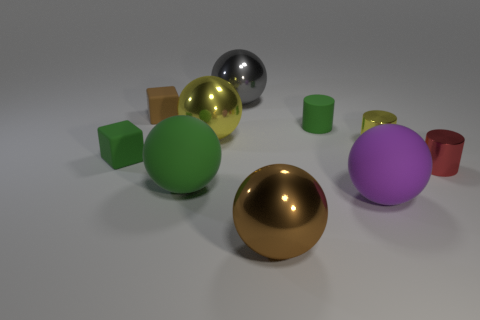Can you describe the surface textures present in the image? Certainly! The image showcases a range of surface textures: the spheres and the cube have glossy, reflective surfaces that would suggest metal or a polished finish; the cylinders exhibit a matte texture, likely indicative of a more diffusive material like plastic or painted wood. Each object's texture interacts distinctively with the light, defining their individual material properties. 